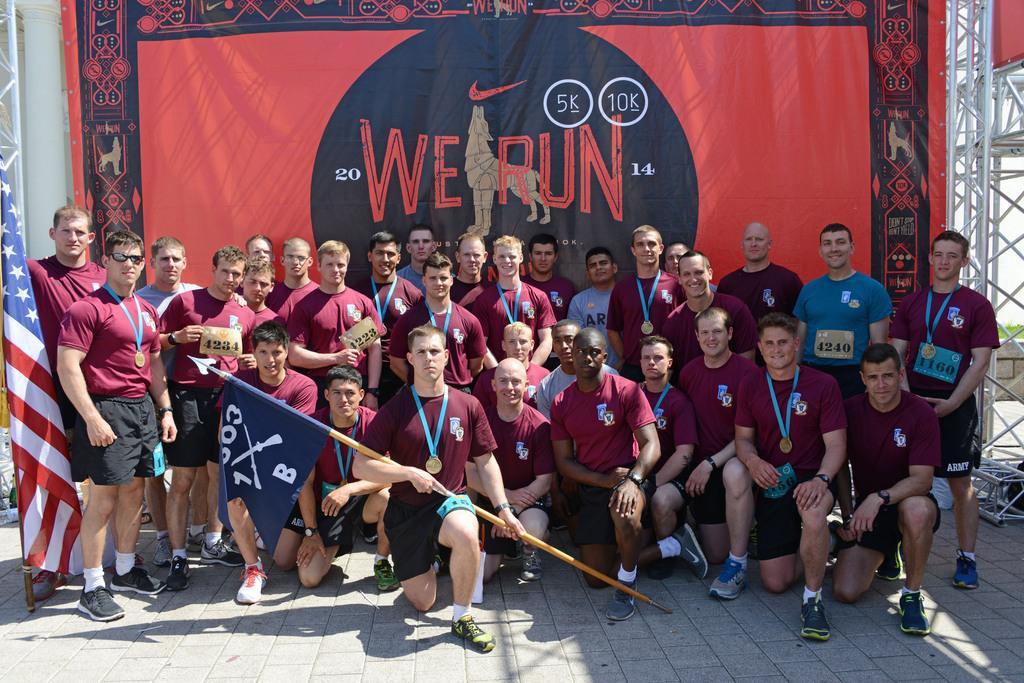Could you give a brief overview of what you see in this image? Here I can see few men wearing t-shirts, shorts, shoes and giving pose for the picture. In the front a man is sitting on the knees and holding a flag in the hands. On the left side, I can see another flag. At the back of these people there is a red color banner on which I can see some text. On the right side there is a pole. 